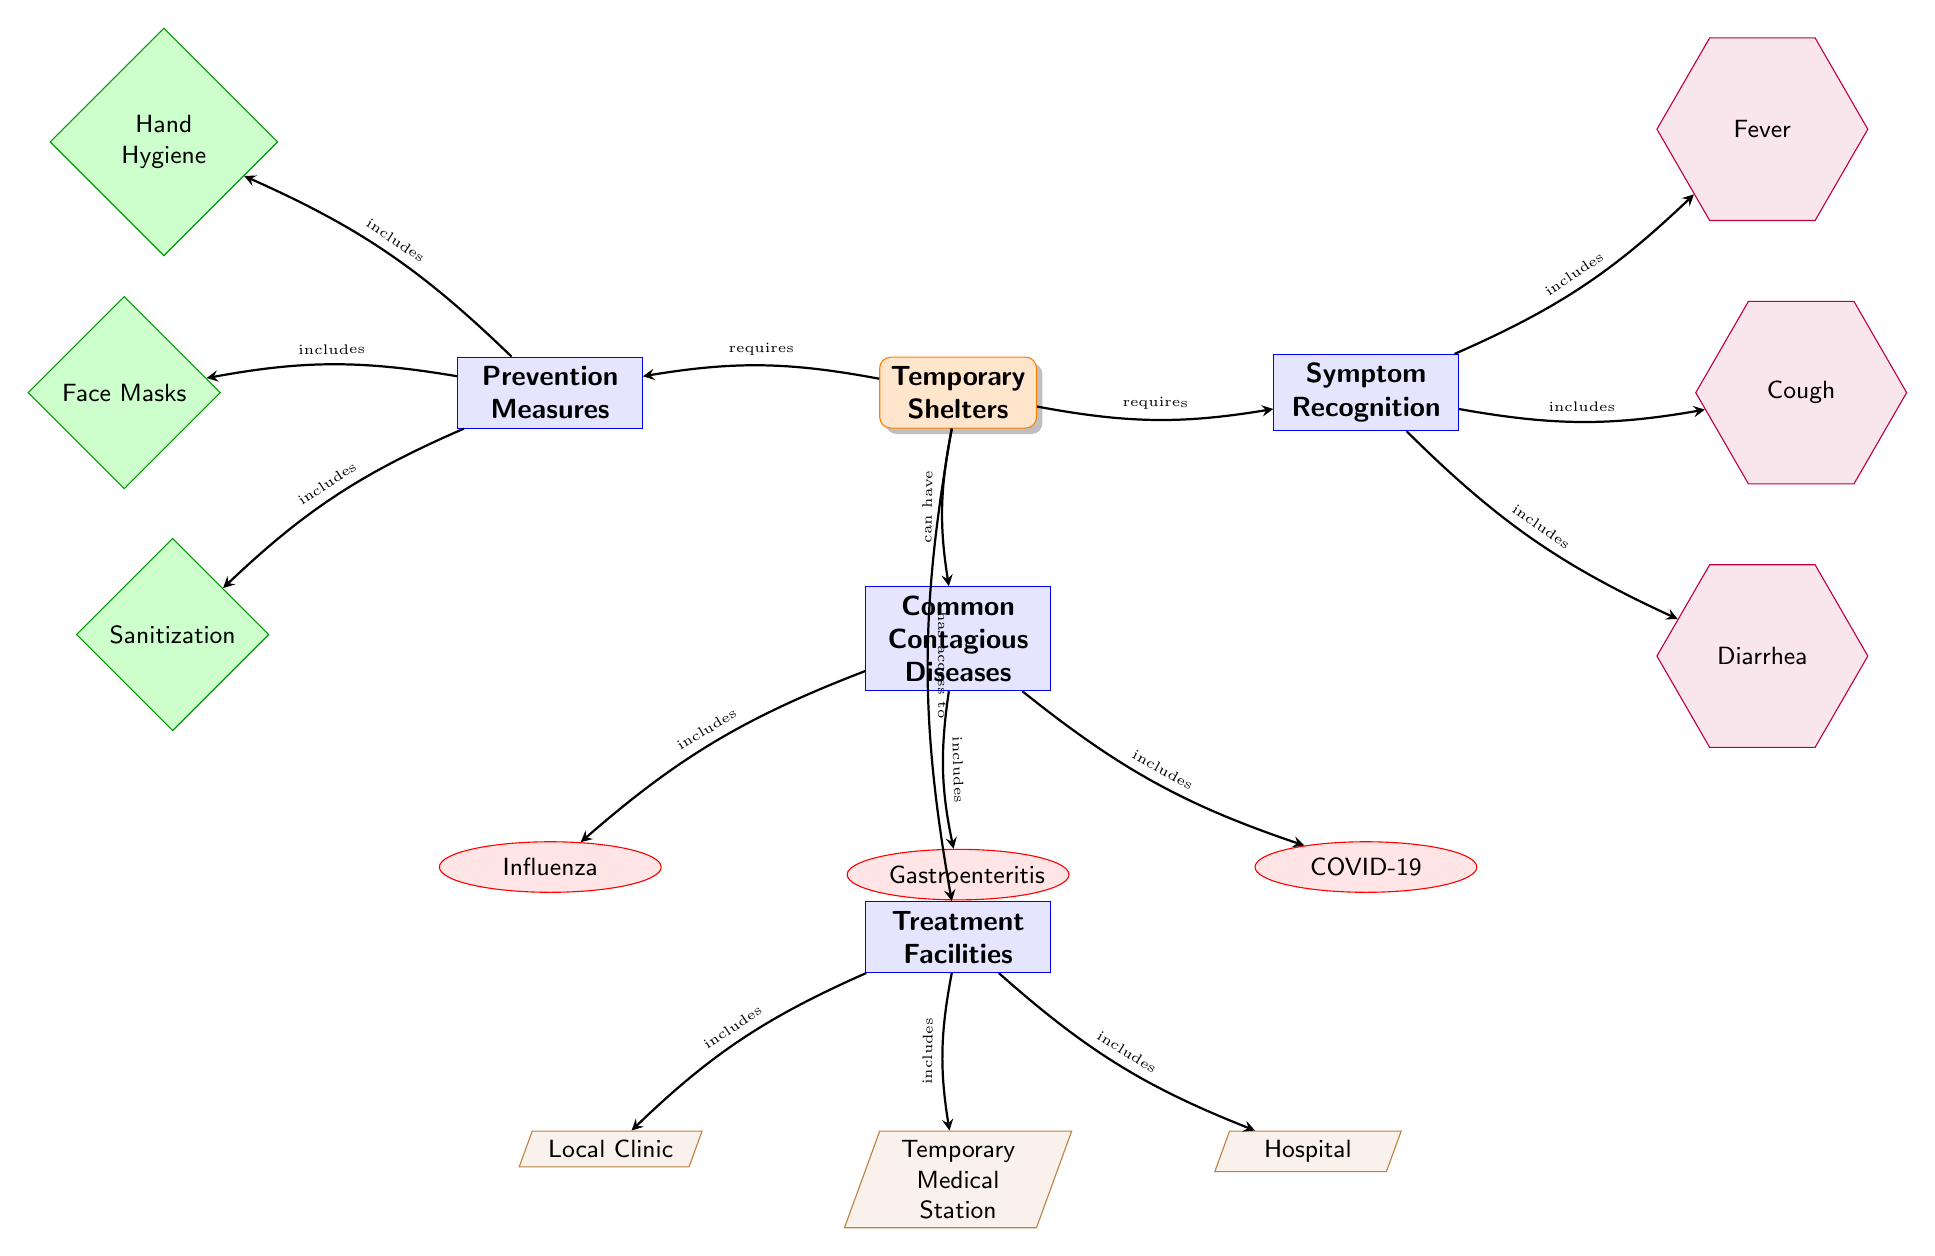What are the common contagious diseases listed in the diagram? The diagram lists three diseases under "Common Contagious Diseases": Influenza, Gastroenteritis, and COVID-19.
Answer: Influenza, Gastroenteritis, COVID-19 What are the prevention measures included? The prevention measures listed include Hand Hygiene, Face Masks, and Sanitization, which are highlighted in the "Prevention Measures" section of the diagram.
Answer: Hand Hygiene, Face Masks, Sanitization How many symptom recognition elements are present? There are three elements listed under "Symptom Recognition": Fever, Cough, and Diarrhea, thus the count is three.
Answer: 3 What is the treatment facility located at the bottom left of the diagram? The treatment facility at the bottom left is labeled "Local Clinic," indicating it is one of the facilities available in temporary shelters.
Answer: Local Clinic How is hand hygiene related to temporary shelters? The diagram shows that temporary shelters require prevention measures, specifically indicating that hand hygiene is an included measure to prevent disease spread.
Answer: requires prevention measures What is the relationship between COVID-19 and local clinics? The diagram shows that COVID-19 is a common contagious disease found in temporary shelters, which are connected to having access to treatment facilities, including local clinics.
Answer: has access to treatment facilities Which symptom is related to Gastroenteritis according to the diagram? The diagram identifies Diarrhea as one of the symptoms recognized, which is commonly associated with Gastroenteritis in temporary shelters.
Answer: Diarrhea What categories are visible on the right of the temporary shelters node? To the right of the "Temporary Shelters" node, there are two categories: "Symptom Recognition" and "Treatment Facilities," emphasizing the need for both awareness of symptoms and access to treatment.
Answer: Symptom Recognition, Treatment Facilities What type of diagram is this? This diagram is a biomedical diagram, as it focuses on the aspect of infectious disease prevention and control within temporary shelters.
Answer: Biomedical Diagram 